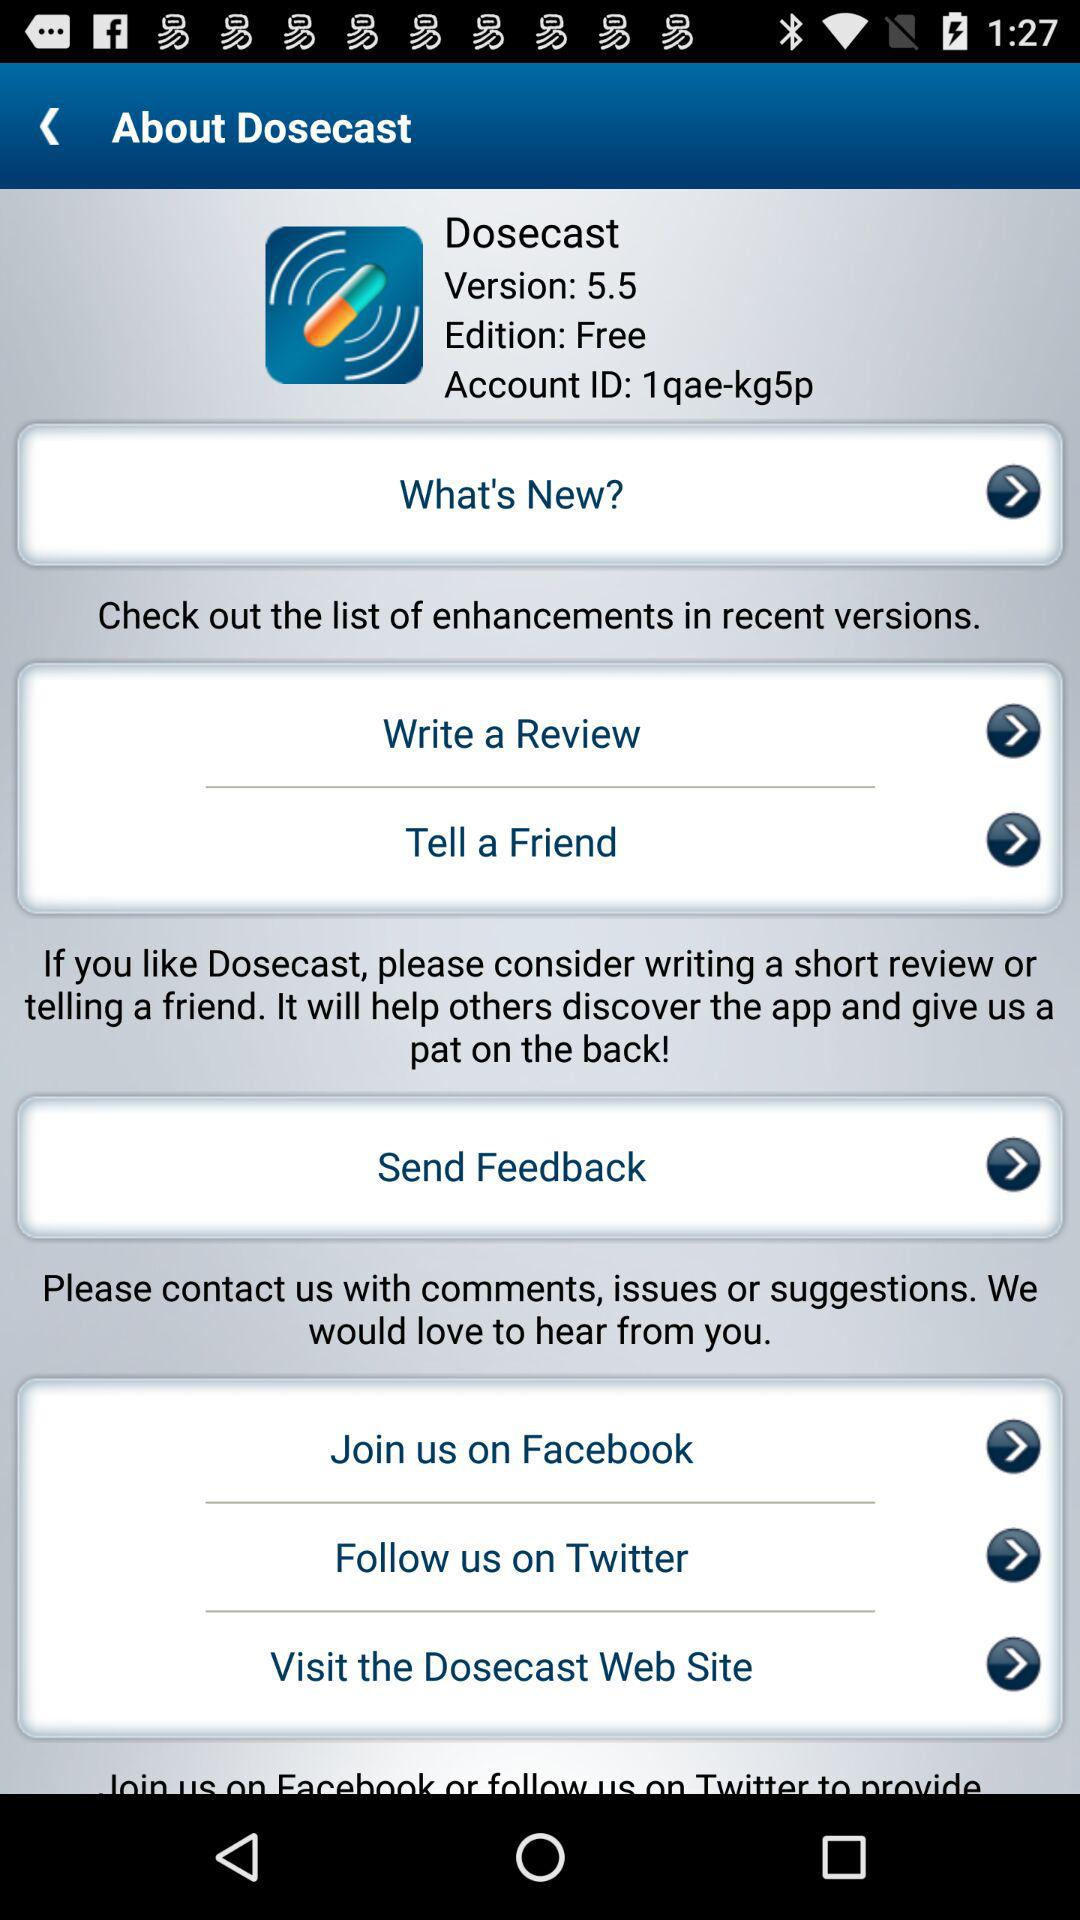What is the account ID? The account ID is 1qae-kg5p. 